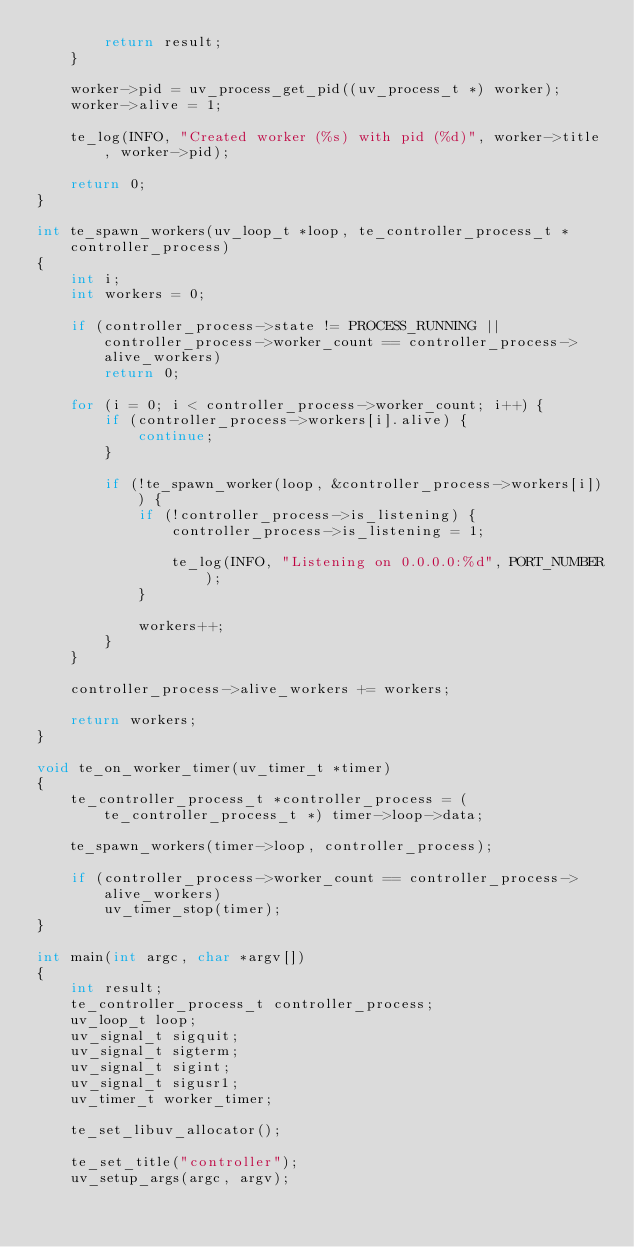Convert code to text. <code><loc_0><loc_0><loc_500><loc_500><_C_>        return result;
    }

    worker->pid = uv_process_get_pid((uv_process_t *) worker);
    worker->alive = 1;

    te_log(INFO, "Created worker (%s) with pid (%d)", worker->title, worker->pid);

    return 0;
}

int te_spawn_workers(uv_loop_t *loop, te_controller_process_t *controller_process)
{
    int i;
    int workers = 0;

    if (controller_process->state != PROCESS_RUNNING || controller_process->worker_count == controller_process->alive_workers)
        return 0;

    for (i = 0; i < controller_process->worker_count; i++) {
        if (controller_process->workers[i].alive) {
            continue;
        }

        if (!te_spawn_worker(loop, &controller_process->workers[i])) {
            if (!controller_process->is_listening) {
                controller_process->is_listening = 1;

                te_log(INFO, "Listening on 0.0.0.0:%d", PORT_NUMBER);
            }

            workers++;
        }
    }

    controller_process->alive_workers += workers;

    return workers;
}

void te_on_worker_timer(uv_timer_t *timer)
{
    te_controller_process_t *controller_process = (te_controller_process_t *) timer->loop->data;

    te_spawn_workers(timer->loop, controller_process);

    if (controller_process->worker_count == controller_process->alive_workers)
        uv_timer_stop(timer);
}

int main(int argc, char *argv[])
{
    int result;
    te_controller_process_t controller_process;
    uv_loop_t loop;
    uv_signal_t sigquit;
    uv_signal_t sigterm;
    uv_signal_t sigint;
    uv_signal_t sigusr1;
    uv_timer_t worker_timer;

    te_set_libuv_allocator();

    te_set_title("controller");
    uv_setup_args(argc, argv);</code> 